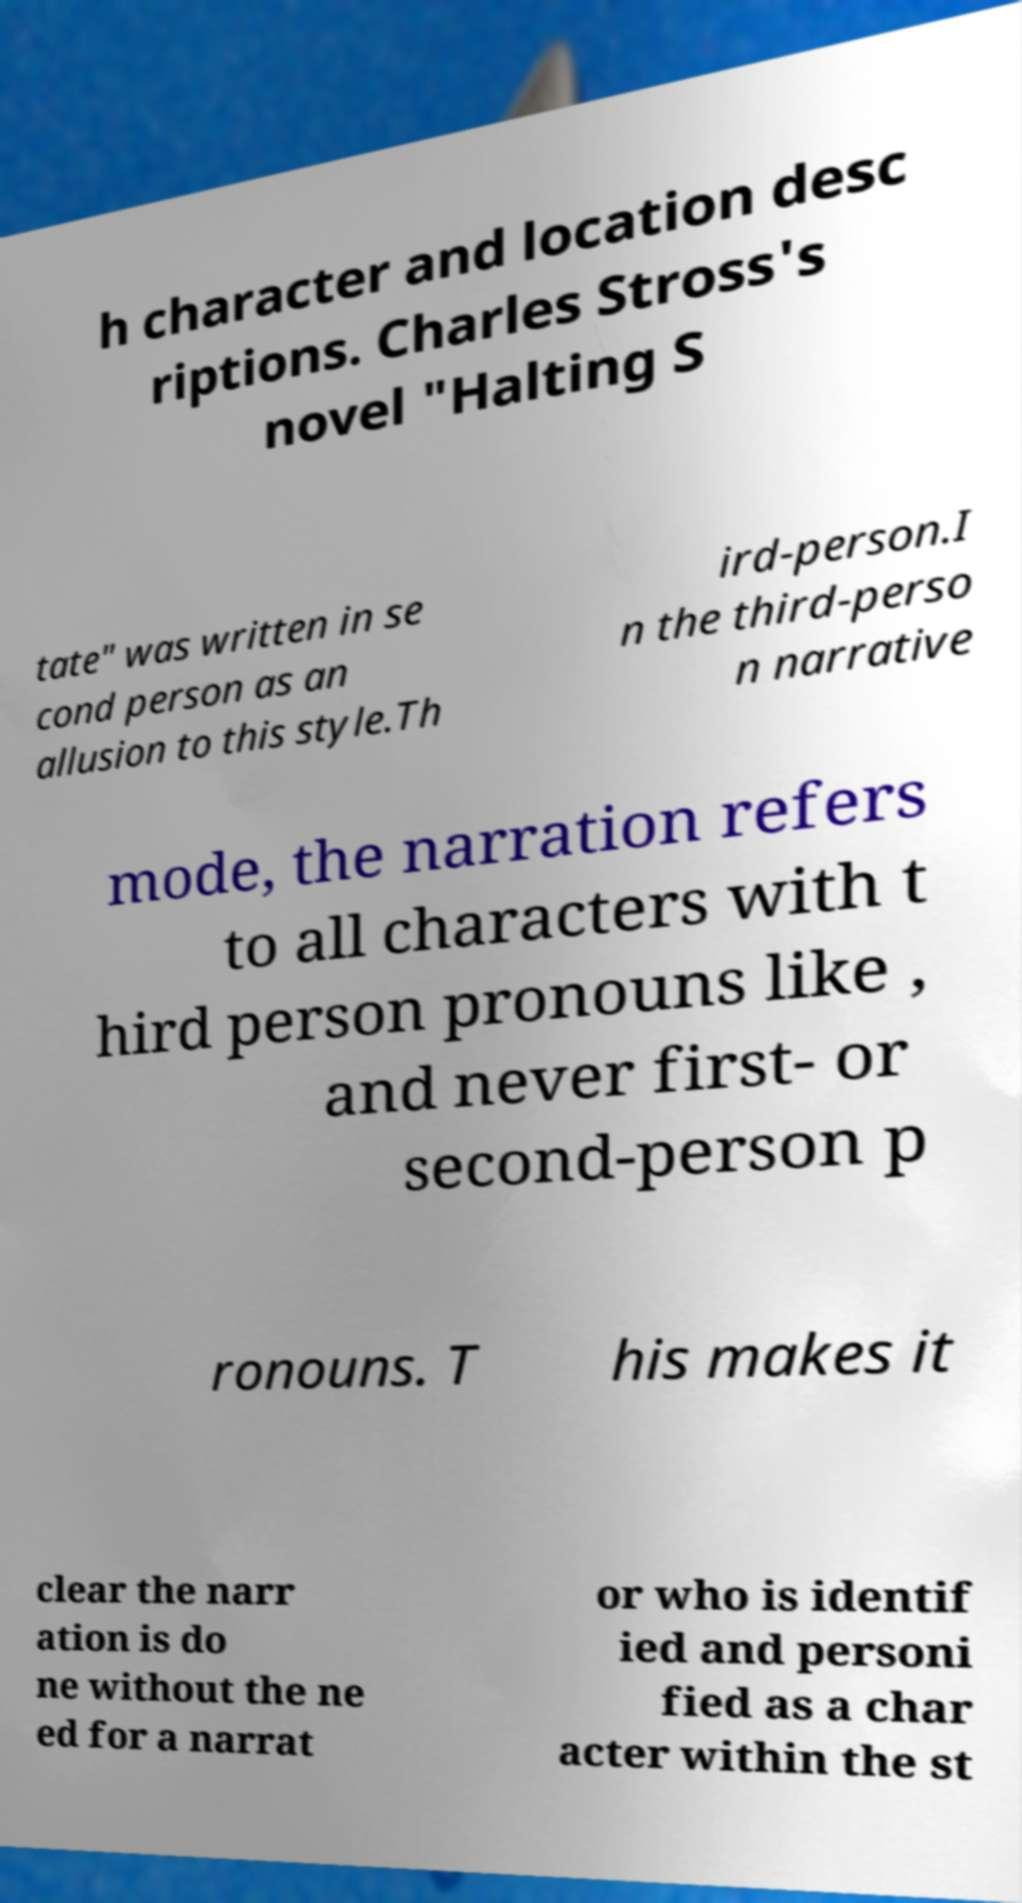Please identify and transcribe the text found in this image. h character and location desc riptions. Charles Stross's novel "Halting S tate" was written in se cond person as an allusion to this style.Th ird-person.I n the third-perso n narrative mode, the narration refers to all characters with t hird person pronouns like , and never first- or second-person p ronouns. T his makes it clear the narr ation is do ne without the ne ed for a narrat or who is identif ied and personi fied as a char acter within the st 